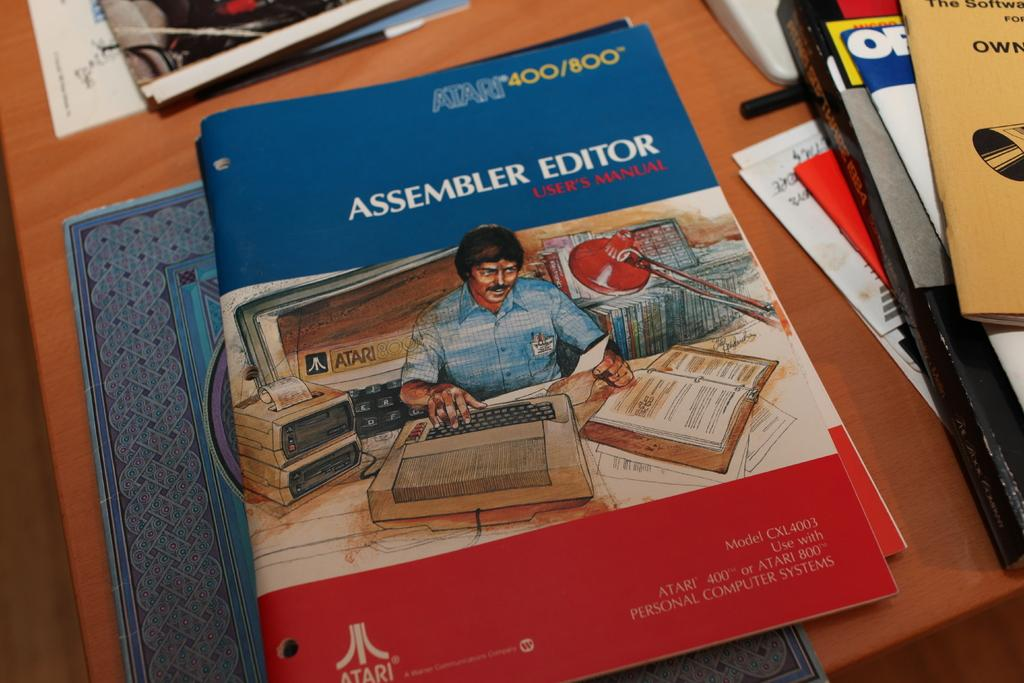<image>
Describe the image concisely. An Assembler Editor User's Manual for the Atari 400/800. 